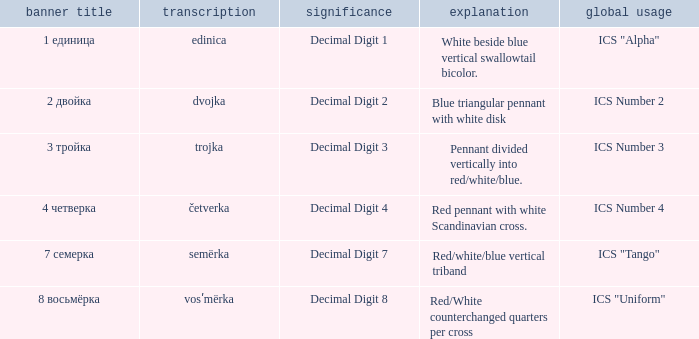What is the name of the flag that means decimal digit 2? 2 двойка. 